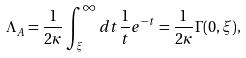Convert formula to latex. <formula><loc_0><loc_0><loc_500><loc_500>\Lambda _ { A } = \frac { 1 } { 2 \kappa } \int ^ { \infty } _ { \xi } d t \frac { 1 } { t } e ^ { - t } = \frac { 1 } { 2 \kappa } \Gamma ( 0 , \xi ) ,</formula> 